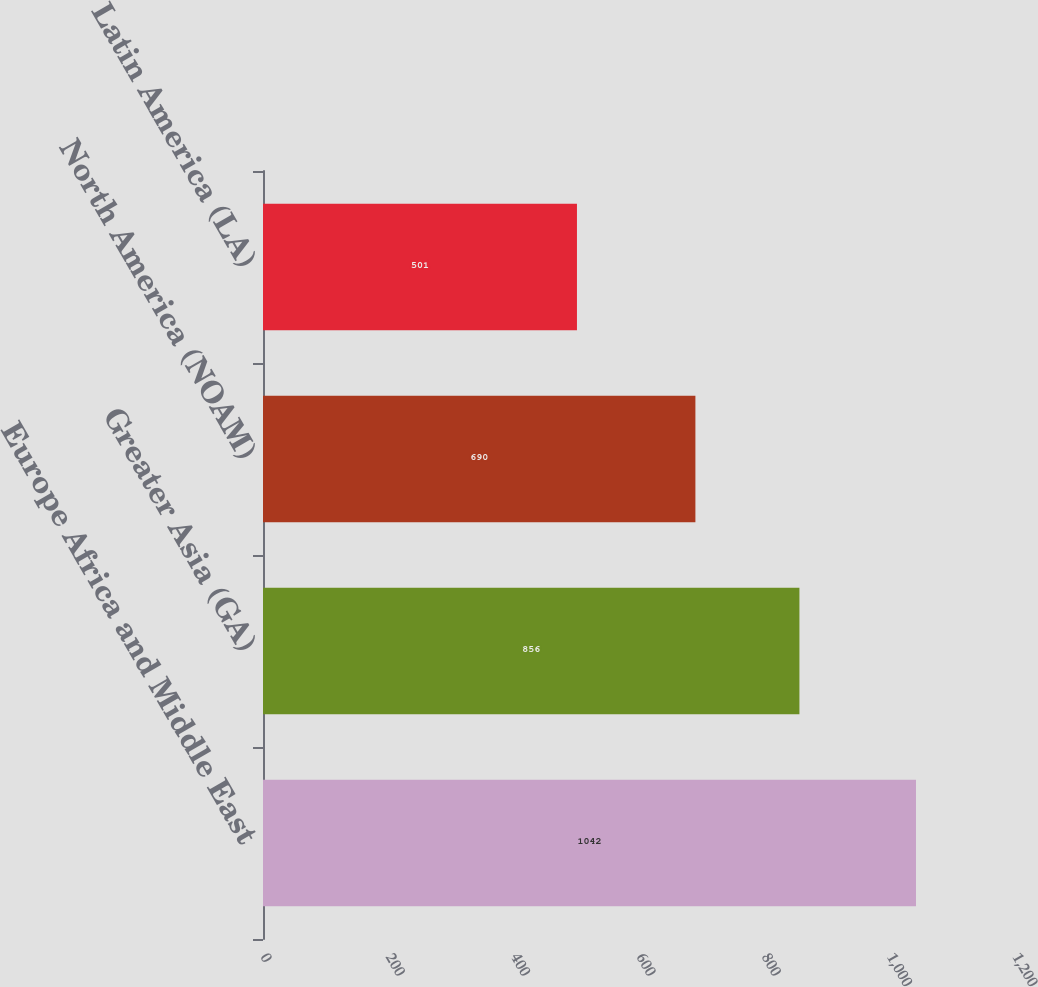Convert chart to OTSL. <chart><loc_0><loc_0><loc_500><loc_500><bar_chart><fcel>Europe Africa and Middle East<fcel>Greater Asia (GA)<fcel>North America (NOAM)<fcel>Latin America (LA)<nl><fcel>1042<fcel>856<fcel>690<fcel>501<nl></chart> 